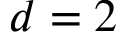<formula> <loc_0><loc_0><loc_500><loc_500>d = 2</formula> 